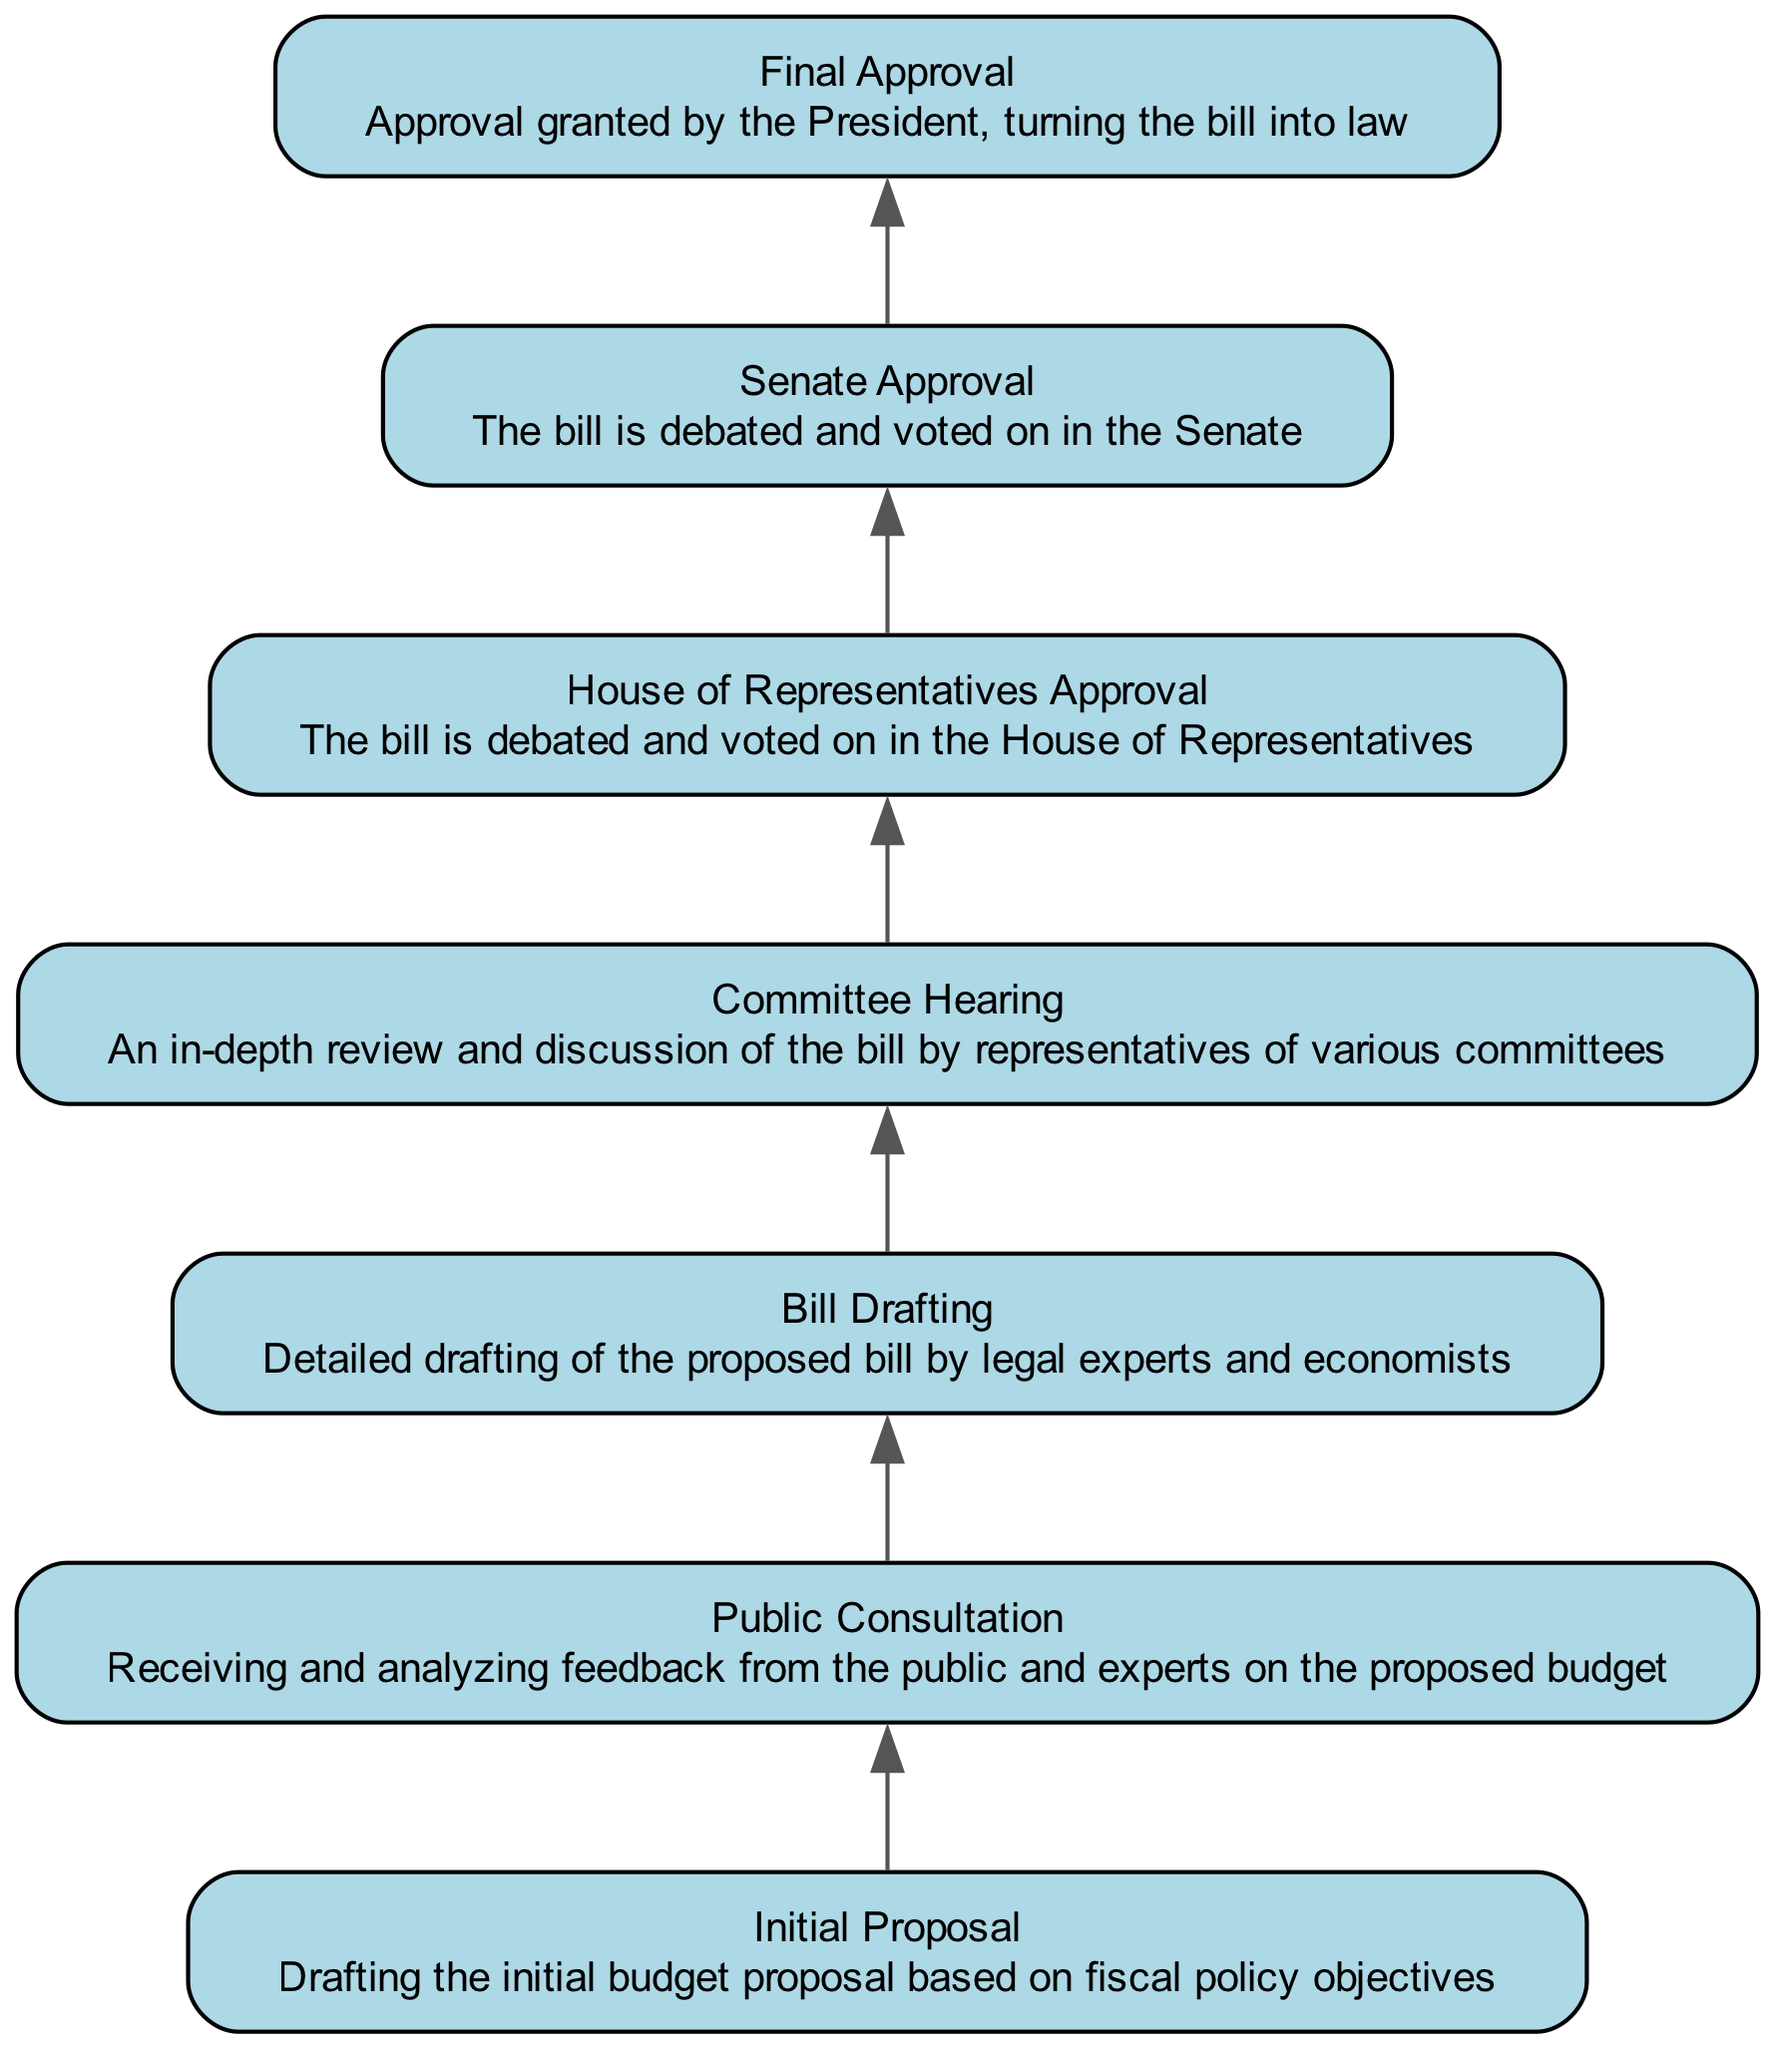What's the final stage of the budget approval process? The final stage, as depicted in the diagram, is "Final Approval," which signifies the approval granted by the President that turns the bill into law.
Answer: Final Approval How many nodes are in the diagram? The diagram contains a total of 6 nodes, which represent distinct stages in the budget approval process from the initial proposal to final approval.
Answer: 6 What is the description of the "House of Representatives Approval"? The description states that in this stage, the bill is debated and voted on in the House of Representatives.
Answer: The bill is debated and voted on in the House of Representatives Which stage directly follows the "Committee Hearing"? According to the diagram, the stage that directly follows "Committee Hearing" is "House of Representatives Approval."
Answer: House of Representatives Approval Which stage relies on the "Public Consultation"? The "Bill Drafting" stage relies on "Public Consultation" as its prerequisite, as indicated in the dependencies within the diagram.
Answer: Bill Drafting What is the sequence of stages from the "Initial Proposal" to "Final Approval"? The sequence starts from "Initial Proposal," followed by "Public Consultation," then "Bill Drafting," followed by "Committee Hearing," then "House of Representatives Approval," and finally "Final Approval."
Answer: Initial Proposal, Public Consultation, Bill Drafting, Committee Hearing, House of Representatives Approval, Final Approval What does the "Committee Hearing" involve? The diagram indicates that "Committee Hearing" involves an in-depth review and discussion of the bill by representatives of various committees.
Answer: An in-depth review and discussion of the bill by representatives of various committees How are the stages connected in terms of dependencies? The dependencies flow from "Initial Proposal" to "Public Consultation," then to "Bill Drafting," followed by "Committee Hearing," then "House of Representatives Approval," and finally leading to "Final Approval," establishing a clear progression through each stage.
Answer: In sequence: Initial Proposal -> Public Consultation -> Bill Drafting -> Committee Hearing -> House of Representatives Approval -> Final Approval Which stage has no dependencies? The "Initial Proposal" stage has no dependencies, as it serves as the starting point in the budget approval process according to the diagram.
Answer: Initial Proposal 